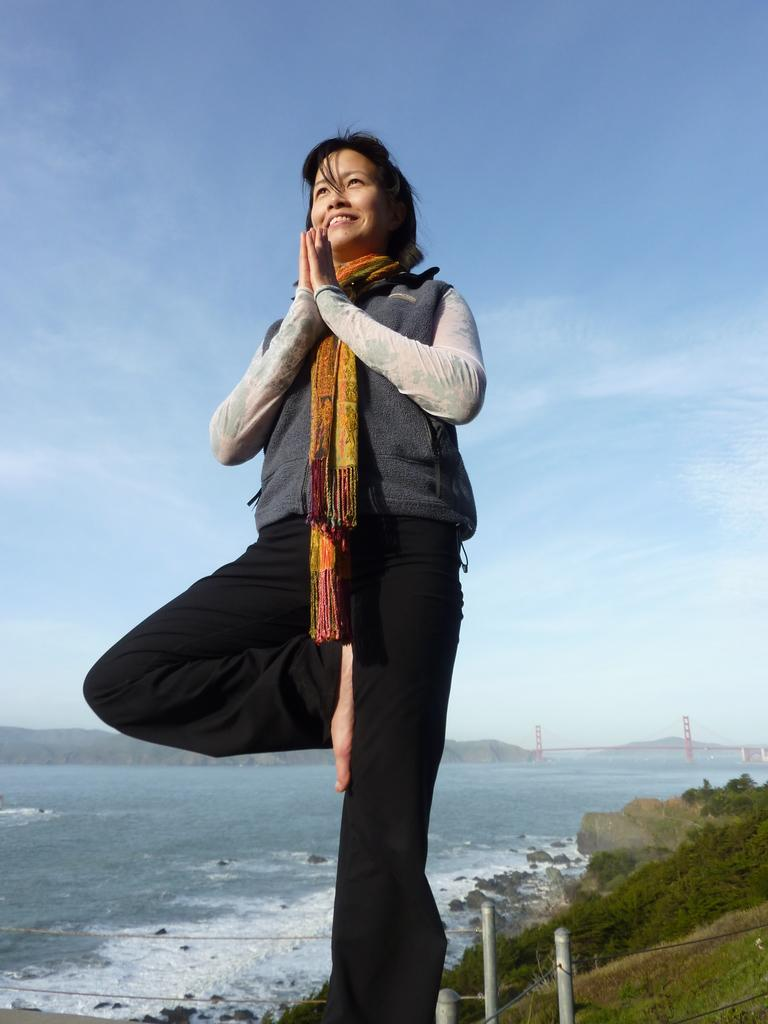What is the person in the image doing? The person is standing on one leg in the image. What can be seen in the background of the image? In the background of the image, there are fences, water, trees, stones in the water, a bridge, mountains, and clouds in the sky. Can you describe the natural features visible in the background? The natural features in the background include water, trees, mountains, and clouds in the sky. What type of structure is present in the background? There is a bridge in the background of the image. How many cats are sitting in the basin in the image? There are no cats or basins present in the image. What type of metal is the zinc bridge made of in the image? There is no mention of a zinc bridge in the image; the bridge is not described in terms of its material. 